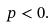<formula> <loc_0><loc_0><loc_500><loc_500>p < 0 .</formula> 